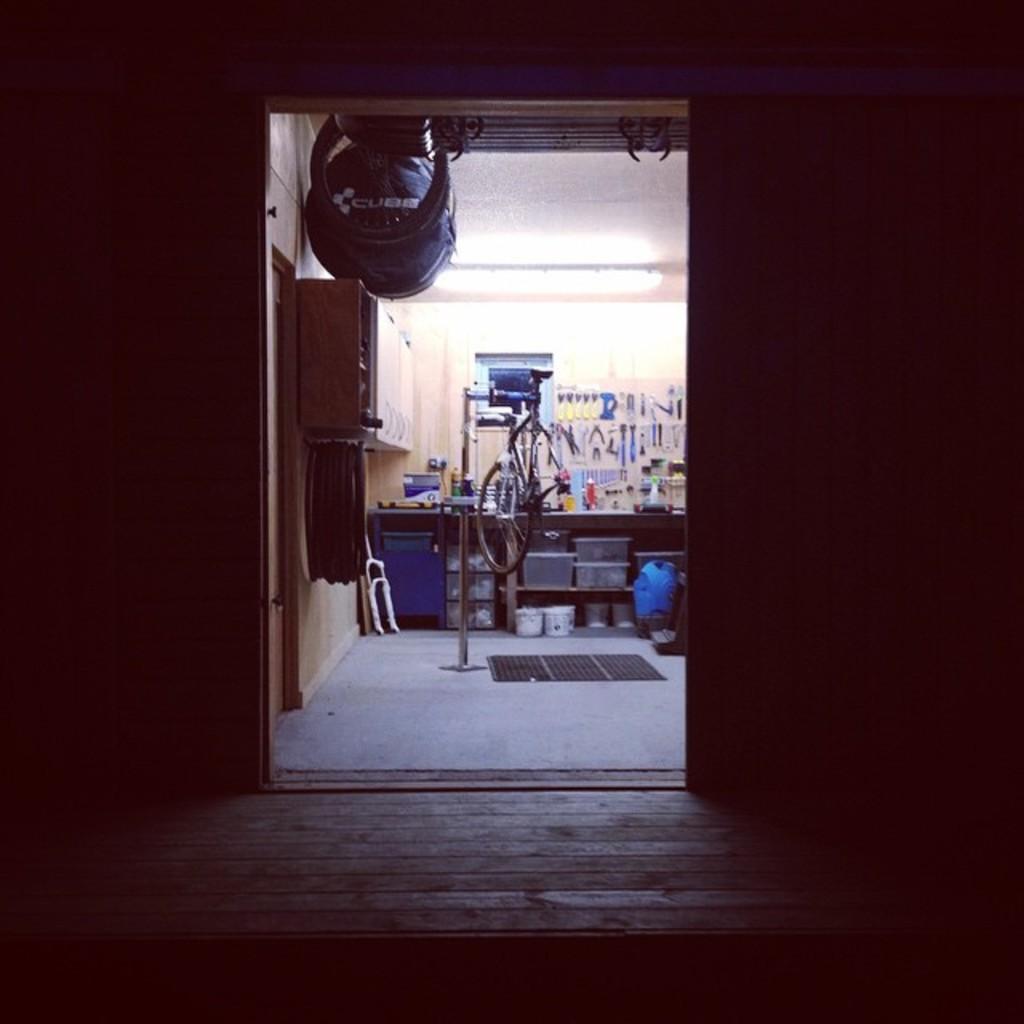Describe this image in one or two sentences. In this image we can see a countertop and there are things placed on the counter top. There are cupboards and there is a light. There is a mat placed on the floor. We can see a door. 